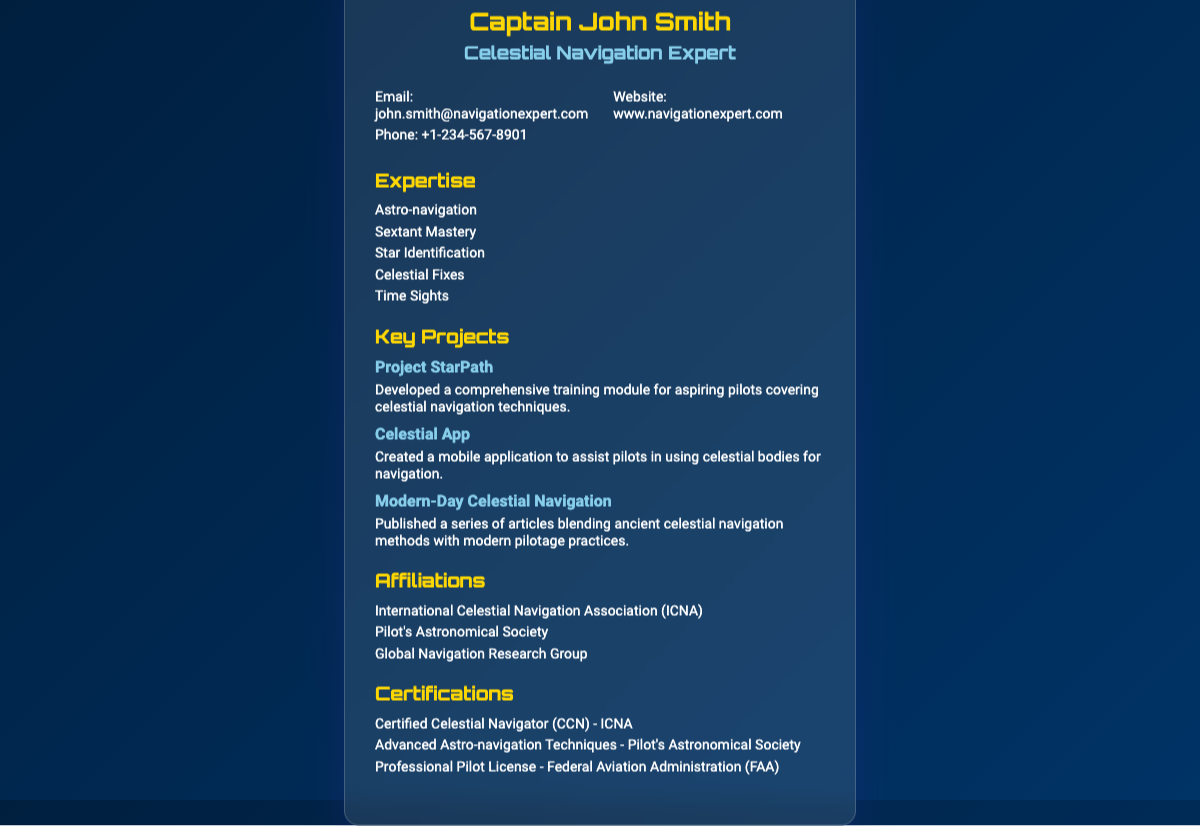What is the name of the expert? The name of the expert is given in the header of the document.
Answer: Captain John Smith What is the main title listed? The main title listed under the name provides the area of expertise.
Answer: Celestial Navigation Expert What is the email address provided? The email address is listed in the contact information section.
Answer: john.smith@navigationexpert.com How many key projects are mentioned? The number of key projects can be counted from the associated heading and listed items.
Answer: 3 What is the first project listed? The first project is found in the key projects section, specifically as the first item.
Answer: Project StarPath Which association is listed as an affiliation? An example of an affiliation can be found in the affiliations section.
Answer: International Celestial Navigation Association (ICNA) What is one certification achieved by John Smith? One certification is highlighted within the certifications section of the document.
Answer: Certified Celestial Navigator (CCN) - ICNA Which mobile application was created? The specific mobile application name is mentioned in the key projects section.
Answer: Celestial App What is the phone number provided? The phone number is part of the contact information in the business card.
Answer: +1-234-567-8901 